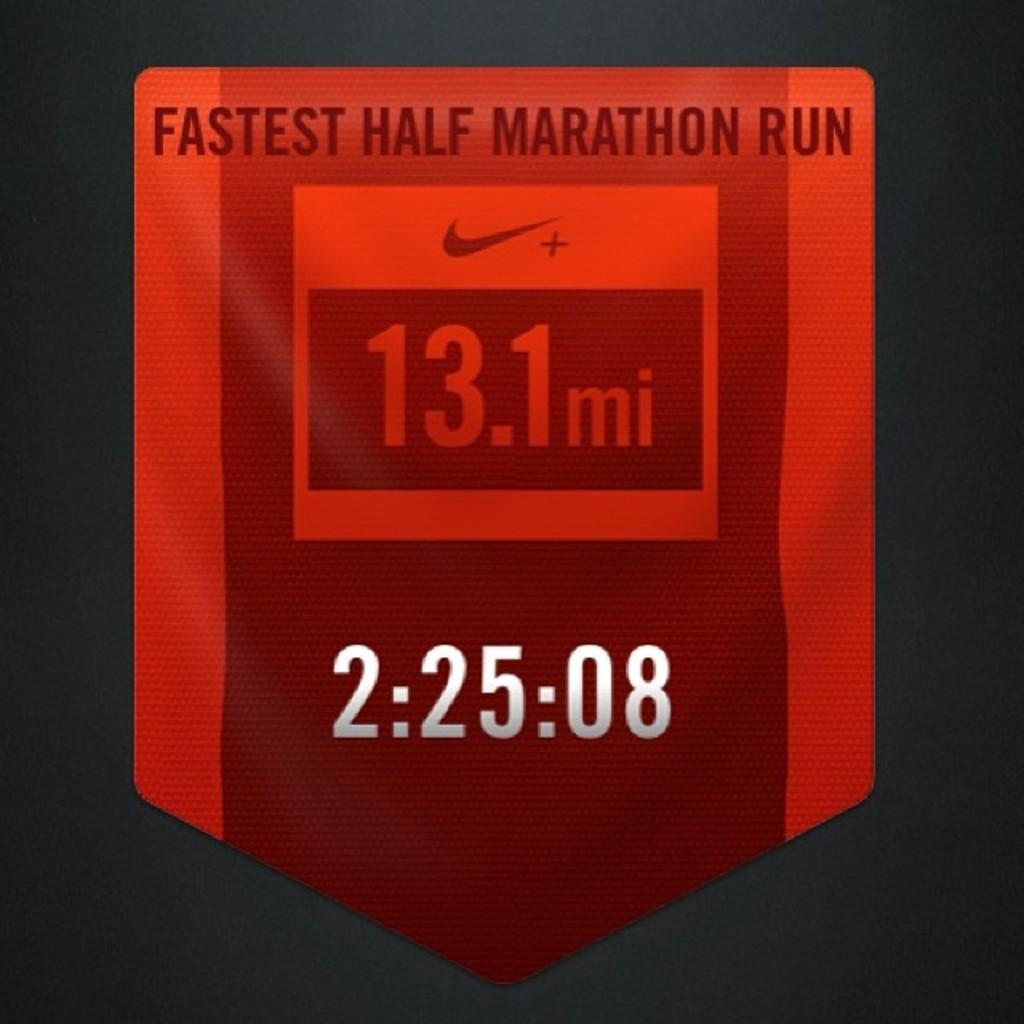<image>
Render a clear and concise summary of the photo. a badge reading Fastest half marathon run 2:25:08 